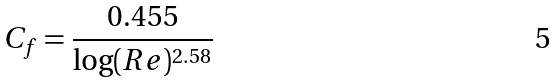Convert formula to latex. <formula><loc_0><loc_0><loc_500><loc_500>C _ { f } = \frac { 0 . 4 5 5 } { \log ( R e ) ^ { 2 . 5 8 } }</formula> 